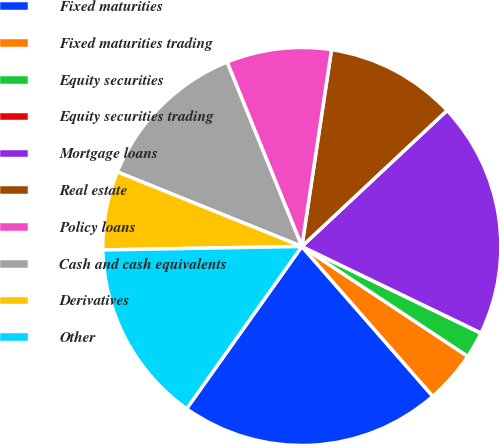Convert chart. <chart><loc_0><loc_0><loc_500><loc_500><pie_chart><fcel>Fixed maturities<fcel>Fixed maturities trading<fcel>Equity securities<fcel>Equity securities trading<fcel>Mortgage loans<fcel>Real estate<fcel>Policy loans<fcel>Cash and cash equivalents<fcel>Derivatives<fcel>Other<nl><fcel>21.26%<fcel>4.26%<fcel>2.14%<fcel>0.01%<fcel>19.14%<fcel>10.64%<fcel>8.51%<fcel>12.76%<fcel>6.39%<fcel>14.89%<nl></chart> 